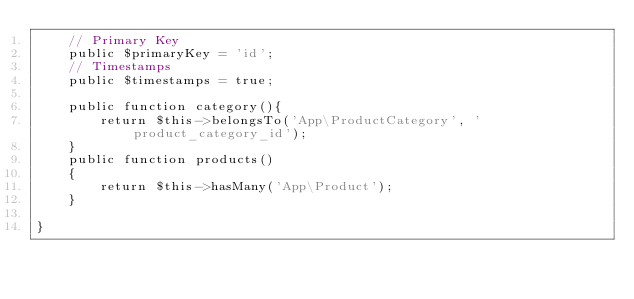Convert code to text. <code><loc_0><loc_0><loc_500><loc_500><_PHP_>    // Primary Key
    public $primaryKey = 'id';
    // Timestamps
    public $timestamps = true;

    public function category(){
        return $this->belongsTo('App\ProductCategory', 'product_category_id');
    }
    public function products()
    {
        return $this->hasMany('App\Product');
    }

}
</code> 